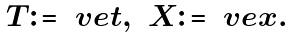Convert formula to latex. <formula><loc_0><loc_0><loc_500><loc_500>\begin{array} { c c } T \colon = \ v e t , & X \colon = \ v e x . \end{array}</formula> 